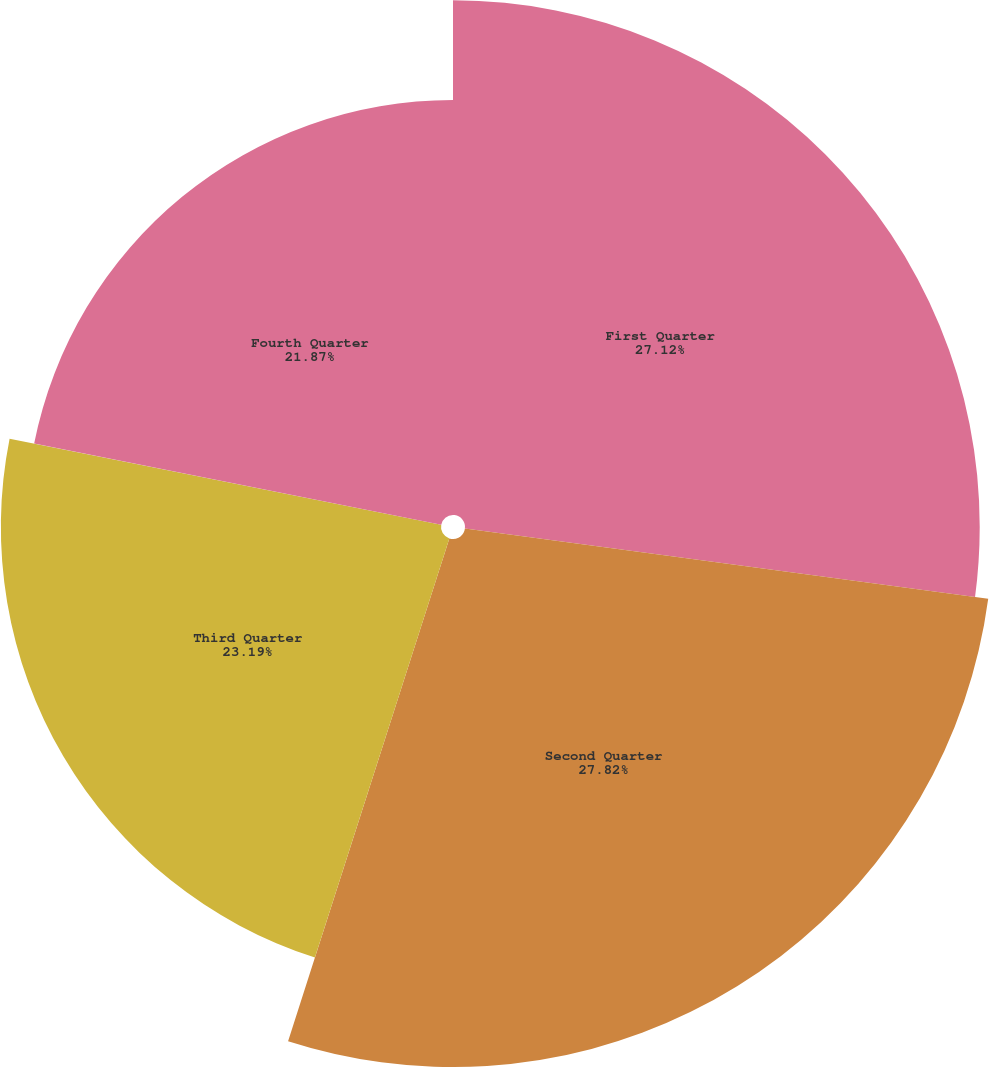<chart> <loc_0><loc_0><loc_500><loc_500><pie_chart><fcel>First Quarter<fcel>Second Quarter<fcel>Third Quarter<fcel>Fourth Quarter<nl><fcel>27.12%<fcel>27.82%<fcel>23.19%<fcel>21.87%<nl></chart> 